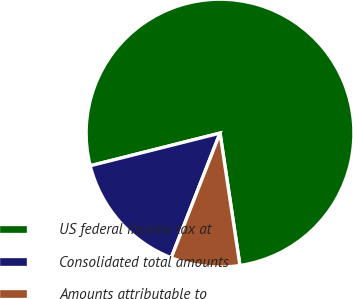Convert chart. <chart><loc_0><loc_0><loc_500><loc_500><pie_chart><fcel>US federal income tax at<fcel>Consolidated total amounts<fcel>Amounts attributable to<nl><fcel>76.55%<fcel>15.14%<fcel>8.31%<nl></chart> 